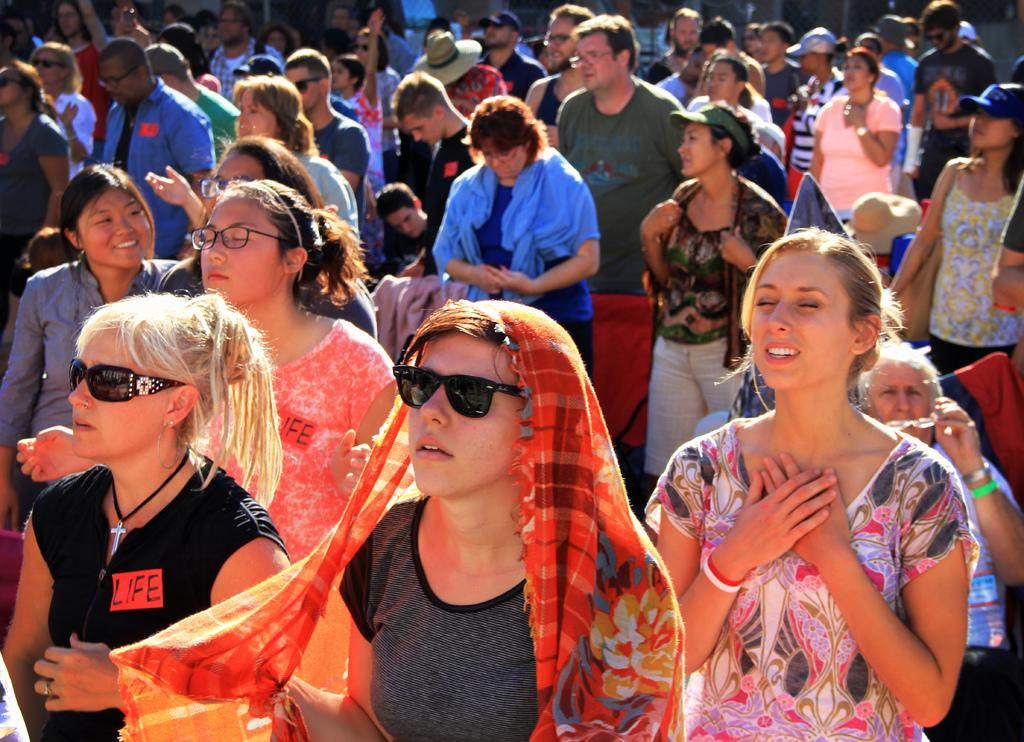How many people are present in the image? There are people in the image, but the exact number is not specified. What type of eyewear can be seen on some of the people? Some of the people are wearing spectacles and some are wearing sunglasses. What type of headwear can be seen on some of the people? Some of the people are wearing caps on their heads. What riddle is written on the page that one of the people is holding in the image? There is no page or riddle present in the image. How does the comb help the person with their hairstyle in the image? There is no comb or person adjusting their hairstyle present in the image. 